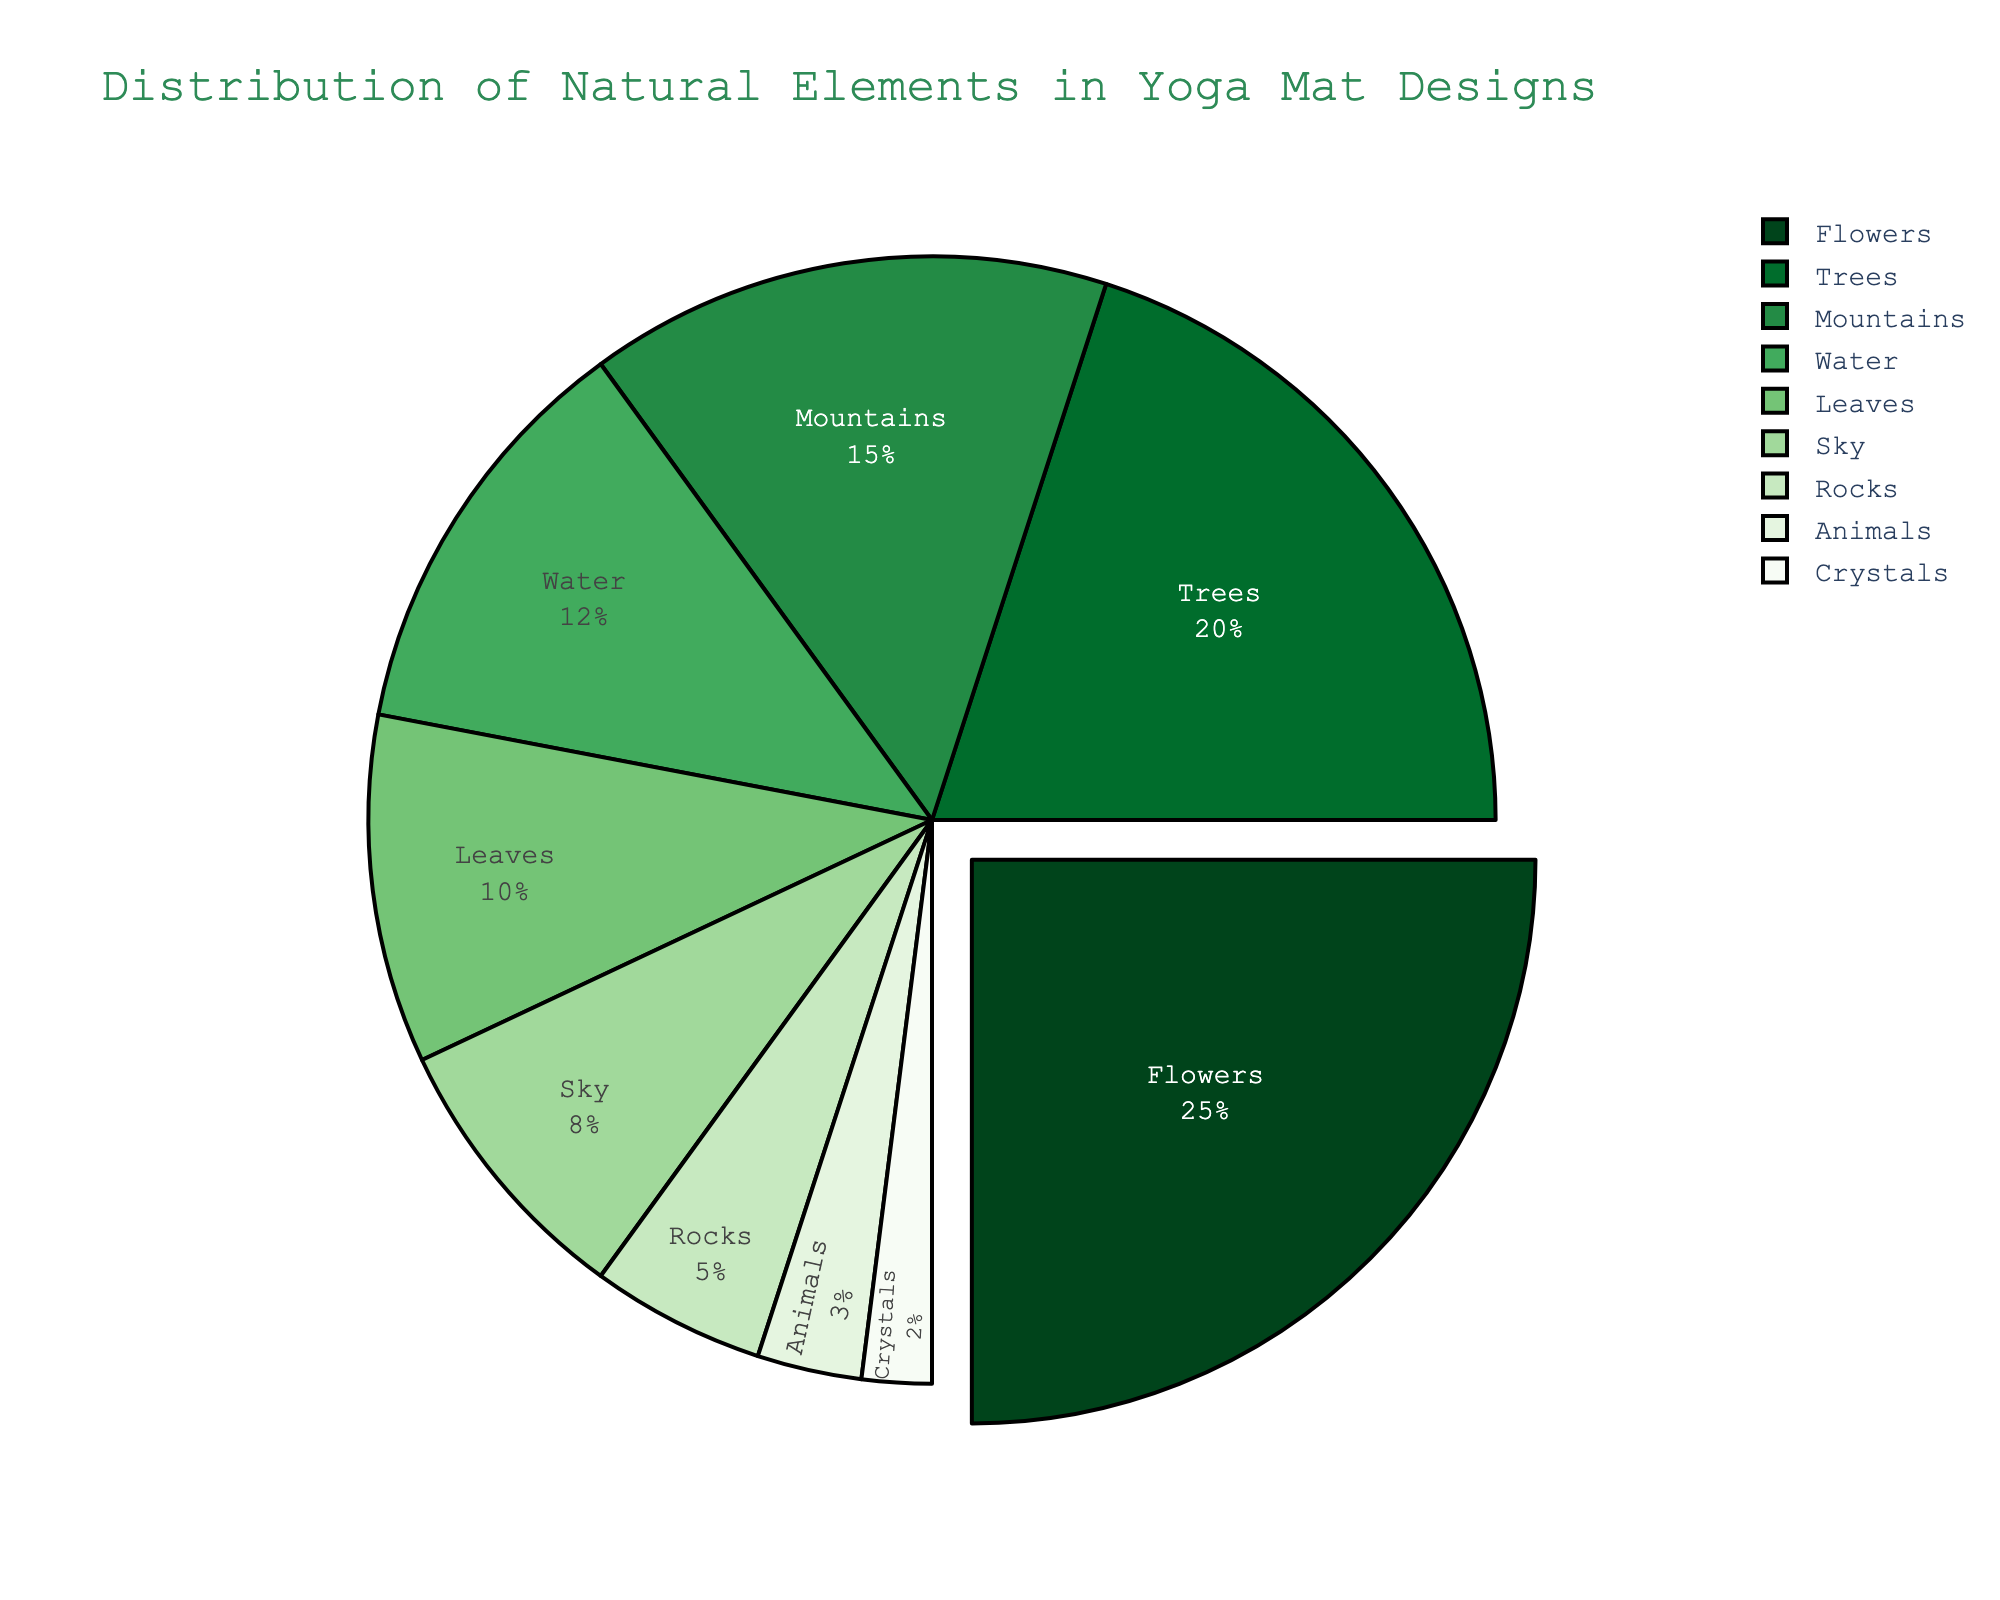What is the most frequently used natural element in yoga mat designs? Identify the section with the largest percentage. Flowers have the highest percentage at 25%.
Answer: Flowers Which natural element is used more, Trees or Mountains? Compare the percentage of Trees (20%) with Mountains (15%). Trees have a higher percentage than Mountains.
Answer: Trees How much more frequently are Water elements used compared to Leaves elements? Subtract the percentage of Leaves (10%) from the percentage of Water (12%). The difference is 2%.
Answer: 2% What is the combined percentage of the least used elements? Add the percentages of Animals (3%) and Crystals (2%). The sum is 3% + 2% = 5%.
Answer: 5% Which elements make up more than half of the total yoga mat designs combined? Sum the percentages of the elements with the highest values until the sum exceeds 50%. Flowers (25%) + Trees (20%) = 45%, adding Mountains (15%) = 60%. So the elements are Flowers, Trees, and Mountains.
Answer: Flowers, Trees, Mountains Are Leaves used more frequently than Sky and Rocks combined? Combine the percentages of Sky (8%) and Rocks (5%). Sky + Rocks = 8% + 5% = 13%. Leaves (10%) has a lower percentage than Sky and Rocks combined.
Answer: No What is the ratio of the use of Flowers to the use of Animals in the designs? Divide the percentage of Flowers (25%) by the percentage of Animals (3%). 25% / 3% = 8.33.
Answer: 8.33 Which natural element has the second lowest usage percentage? Rank the elements by percentage and identify the second lowest. Crystals have the lowest (2%) and Animals have the second lowest (3%).
Answer: Animals 